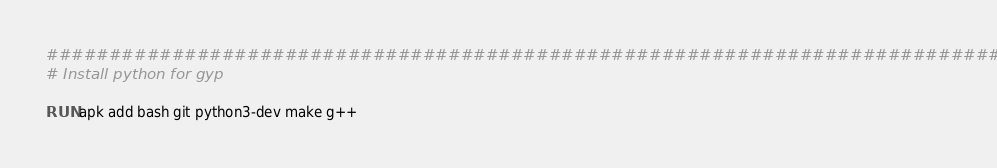Convert code to text. <code><loc_0><loc_0><loc_500><loc_500><_Dockerfile_>################################################################################
# Install python for gyp

RUN apk add bash git python3-dev make g++


</code> 